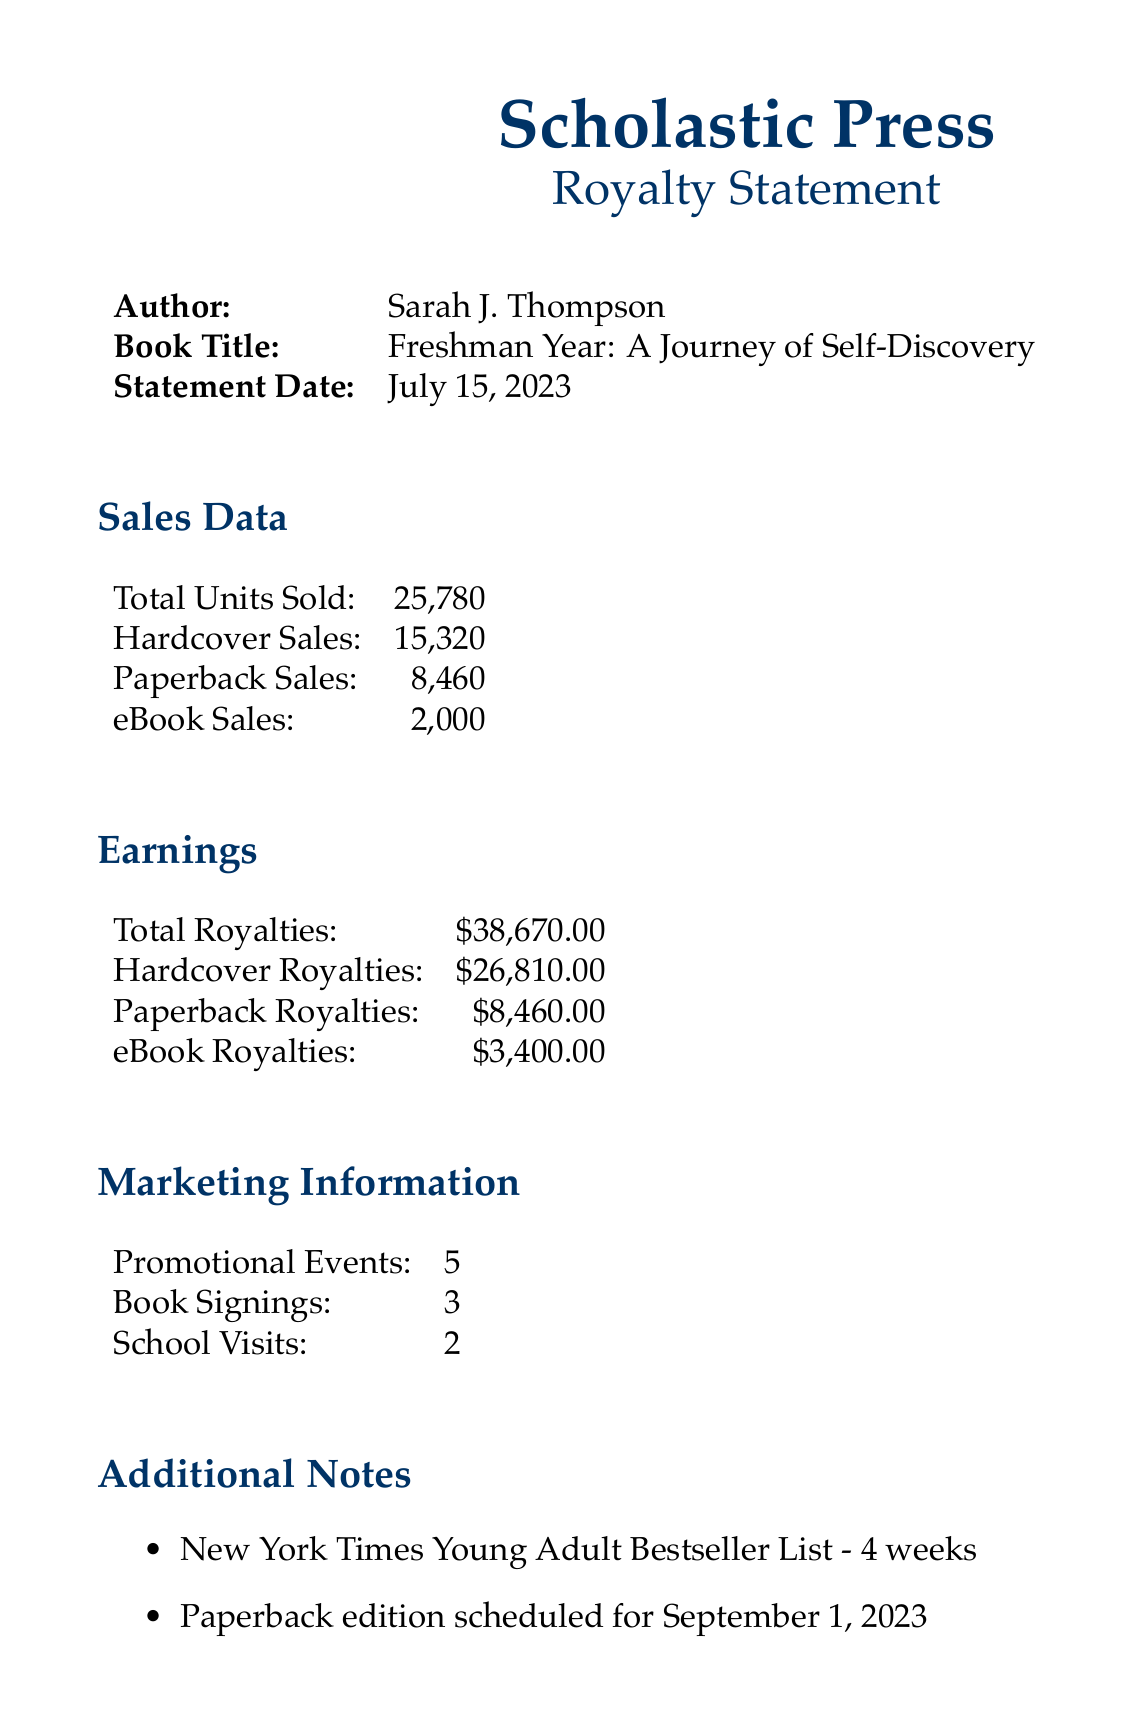What is the author’s name? The author’s name is listed in the document under the author section.
Answer: Sarah J. Thompson What is the title of the book? The title of the book is shown in the corresponding section of the document.
Answer: Freshman Year: A Journey of Self-Discovery On what date was the royalty statement issued? The statement date is indicated in the document.
Answer: July 15, 2023 How many hardcover books were sold? The number of hardcover sales can be found in the sales data section.
Answer: 15,320 What is the total royalties amount? The total royalties figure is provided in the earnings section.
Answer: $38,670.00 How many promotional events were held? The number of promotional events is listed under the marketing information section.
Answer: 5 What was the duration on the New York Times Young Adult Bestseller List? This information is mentioned under the additional notes section, referring to its performance on the list.
Answer: 4 weeks How many book signings took place? The number of book signings is specified in the marketing information.
Answer: 3 Who is the Royalties Manager? The name of the royalties manager is found in the publisher contact section of the document.
Answer: Emily Roberts 